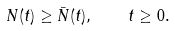<formula> <loc_0><loc_0><loc_500><loc_500>N ( t ) \geq \bar { N } ( t ) , \quad t \geq 0 .</formula> 